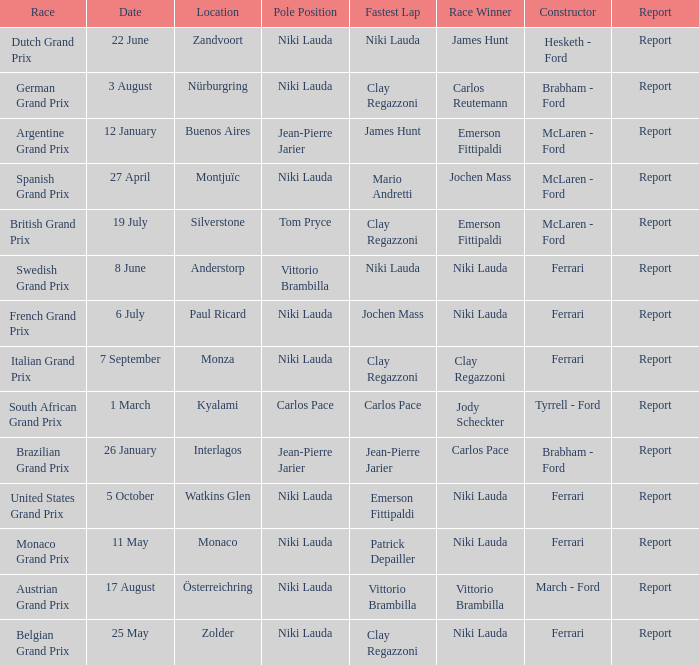Where did the team in which Tom Pryce was in Pole Position race? Silverstone. 